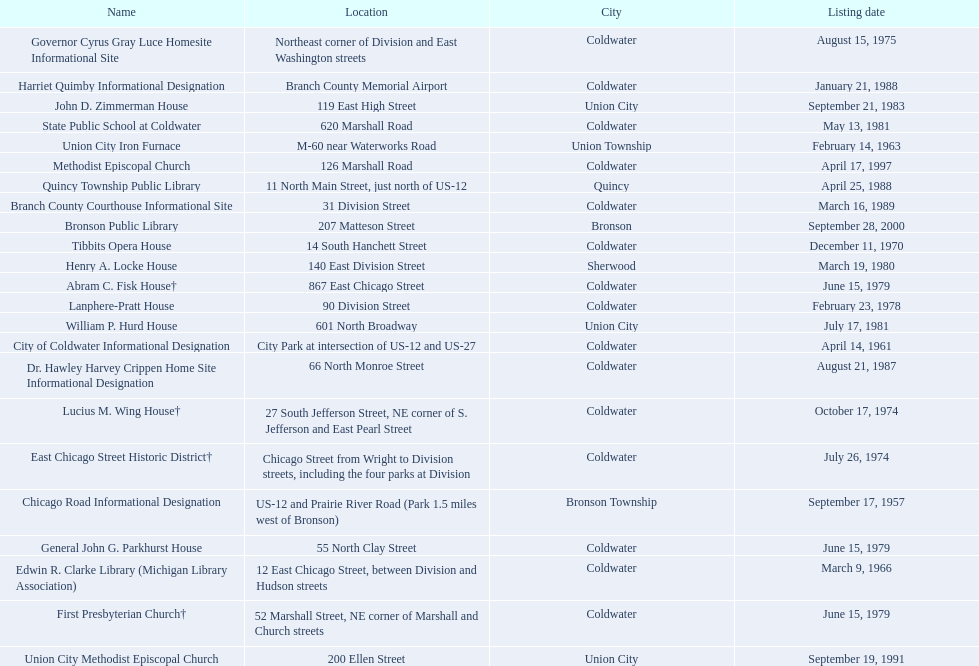How many years passed between the historic listing of public libraries in quincy and bronson? 12. 